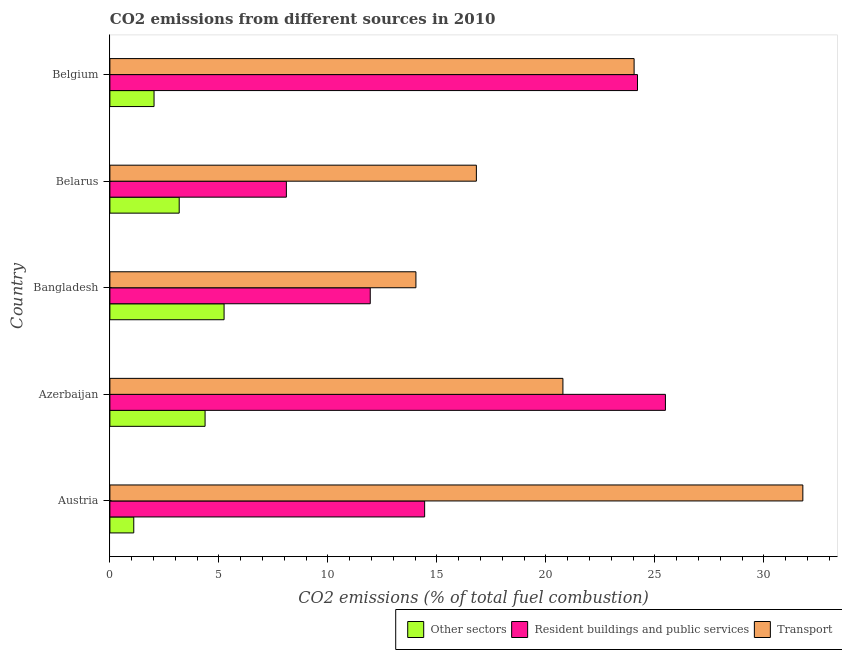How many groups of bars are there?
Your answer should be compact. 5. Are the number of bars on each tick of the Y-axis equal?
Provide a succinct answer. Yes. What is the percentage of co2 emissions from other sectors in Azerbaijan?
Provide a succinct answer. 4.37. Across all countries, what is the maximum percentage of co2 emissions from other sectors?
Offer a terse response. 5.24. Across all countries, what is the minimum percentage of co2 emissions from transport?
Give a very brief answer. 14.04. In which country was the percentage of co2 emissions from other sectors maximum?
Make the answer very short. Bangladesh. In which country was the percentage of co2 emissions from resident buildings and public services minimum?
Provide a short and direct response. Belarus. What is the total percentage of co2 emissions from other sectors in the graph?
Give a very brief answer. 15.9. What is the difference between the percentage of co2 emissions from resident buildings and public services in Azerbaijan and that in Belgium?
Provide a short and direct response. 1.28. What is the difference between the percentage of co2 emissions from transport in Bangladesh and the percentage of co2 emissions from other sectors in Azerbaijan?
Keep it short and to the point. 9.67. What is the average percentage of co2 emissions from other sectors per country?
Make the answer very short. 3.18. What is the difference between the percentage of co2 emissions from other sectors and percentage of co2 emissions from resident buildings and public services in Bangladesh?
Provide a succinct answer. -6.71. What is the ratio of the percentage of co2 emissions from transport in Austria to that in Belarus?
Offer a terse response. 1.89. Is the percentage of co2 emissions from transport in Bangladesh less than that in Belgium?
Provide a succinct answer. Yes. Is the difference between the percentage of co2 emissions from transport in Belarus and Belgium greater than the difference between the percentage of co2 emissions from resident buildings and public services in Belarus and Belgium?
Provide a succinct answer. Yes. What is the difference between the highest and the second highest percentage of co2 emissions from transport?
Keep it short and to the point. 7.74. What is the difference between the highest and the lowest percentage of co2 emissions from resident buildings and public services?
Your answer should be very brief. 17.39. What does the 2nd bar from the top in Austria represents?
Ensure brevity in your answer.  Resident buildings and public services. What does the 3rd bar from the bottom in Belarus represents?
Your response must be concise. Transport. Is it the case that in every country, the sum of the percentage of co2 emissions from other sectors and percentage of co2 emissions from resident buildings and public services is greater than the percentage of co2 emissions from transport?
Give a very brief answer. No. How many bars are there?
Offer a very short reply. 15. How many countries are there in the graph?
Give a very brief answer. 5. Are the values on the major ticks of X-axis written in scientific E-notation?
Your response must be concise. No. Does the graph contain any zero values?
Provide a short and direct response. No. Does the graph contain grids?
Your answer should be very brief. No. How are the legend labels stacked?
Offer a very short reply. Horizontal. What is the title of the graph?
Ensure brevity in your answer.  CO2 emissions from different sources in 2010. What is the label or title of the X-axis?
Keep it short and to the point. CO2 emissions (% of total fuel combustion). What is the label or title of the Y-axis?
Keep it short and to the point. Country. What is the CO2 emissions (% of total fuel combustion) in Other sectors in Austria?
Make the answer very short. 1.1. What is the CO2 emissions (% of total fuel combustion) in Resident buildings and public services in Austria?
Offer a very short reply. 14.44. What is the CO2 emissions (% of total fuel combustion) of Transport in Austria?
Offer a very short reply. 31.79. What is the CO2 emissions (% of total fuel combustion) of Other sectors in Azerbaijan?
Give a very brief answer. 4.37. What is the CO2 emissions (% of total fuel combustion) in Resident buildings and public services in Azerbaijan?
Your answer should be very brief. 25.48. What is the CO2 emissions (% of total fuel combustion) in Transport in Azerbaijan?
Your answer should be very brief. 20.78. What is the CO2 emissions (% of total fuel combustion) of Other sectors in Bangladesh?
Offer a terse response. 5.24. What is the CO2 emissions (% of total fuel combustion) of Resident buildings and public services in Bangladesh?
Your response must be concise. 11.94. What is the CO2 emissions (% of total fuel combustion) in Transport in Bangladesh?
Offer a very short reply. 14.04. What is the CO2 emissions (% of total fuel combustion) in Other sectors in Belarus?
Give a very brief answer. 3.18. What is the CO2 emissions (% of total fuel combustion) in Resident buildings and public services in Belarus?
Your answer should be very brief. 8.1. What is the CO2 emissions (% of total fuel combustion) of Transport in Belarus?
Keep it short and to the point. 16.81. What is the CO2 emissions (% of total fuel combustion) of Other sectors in Belgium?
Offer a very short reply. 2.03. What is the CO2 emissions (% of total fuel combustion) of Resident buildings and public services in Belgium?
Make the answer very short. 24.2. What is the CO2 emissions (% of total fuel combustion) of Transport in Belgium?
Ensure brevity in your answer.  24.05. Across all countries, what is the maximum CO2 emissions (% of total fuel combustion) of Other sectors?
Your answer should be very brief. 5.24. Across all countries, what is the maximum CO2 emissions (% of total fuel combustion) in Resident buildings and public services?
Your answer should be compact. 25.48. Across all countries, what is the maximum CO2 emissions (% of total fuel combustion) of Transport?
Ensure brevity in your answer.  31.79. Across all countries, what is the minimum CO2 emissions (% of total fuel combustion) in Other sectors?
Provide a short and direct response. 1.1. Across all countries, what is the minimum CO2 emissions (% of total fuel combustion) of Resident buildings and public services?
Give a very brief answer. 8.1. Across all countries, what is the minimum CO2 emissions (% of total fuel combustion) in Transport?
Give a very brief answer. 14.04. What is the total CO2 emissions (% of total fuel combustion) of Other sectors in the graph?
Provide a short and direct response. 15.9. What is the total CO2 emissions (% of total fuel combustion) in Resident buildings and public services in the graph?
Provide a succinct answer. 84.16. What is the total CO2 emissions (% of total fuel combustion) in Transport in the graph?
Offer a very short reply. 107.46. What is the difference between the CO2 emissions (% of total fuel combustion) of Other sectors in Austria and that in Azerbaijan?
Make the answer very short. -3.27. What is the difference between the CO2 emissions (% of total fuel combustion) of Resident buildings and public services in Austria and that in Azerbaijan?
Provide a succinct answer. -11.04. What is the difference between the CO2 emissions (% of total fuel combustion) in Transport in Austria and that in Azerbaijan?
Give a very brief answer. 11.01. What is the difference between the CO2 emissions (% of total fuel combustion) in Other sectors in Austria and that in Bangladesh?
Make the answer very short. -4.14. What is the difference between the CO2 emissions (% of total fuel combustion) in Resident buildings and public services in Austria and that in Bangladesh?
Offer a very short reply. 2.5. What is the difference between the CO2 emissions (% of total fuel combustion) of Transport in Austria and that in Bangladesh?
Make the answer very short. 17.75. What is the difference between the CO2 emissions (% of total fuel combustion) of Other sectors in Austria and that in Belarus?
Offer a terse response. -2.08. What is the difference between the CO2 emissions (% of total fuel combustion) in Resident buildings and public services in Austria and that in Belarus?
Provide a short and direct response. 6.34. What is the difference between the CO2 emissions (% of total fuel combustion) in Transport in Austria and that in Belarus?
Give a very brief answer. 14.98. What is the difference between the CO2 emissions (% of total fuel combustion) of Other sectors in Austria and that in Belgium?
Your response must be concise. -0.93. What is the difference between the CO2 emissions (% of total fuel combustion) in Resident buildings and public services in Austria and that in Belgium?
Your answer should be compact. -9.76. What is the difference between the CO2 emissions (% of total fuel combustion) in Transport in Austria and that in Belgium?
Ensure brevity in your answer.  7.74. What is the difference between the CO2 emissions (% of total fuel combustion) in Other sectors in Azerbaijan and that in Bangladesh?
Offer a terse response. -0.87. What is the difference between the CO2 emissions (% of total fuel combustion) in Resident buildings and public services in Azerbaijan and that in Bangladesh?
Your response must be concise. 13.54. What is the difference between the CO2 emissions (% of total fuel combustion) in Transport in Azerbaijan and that in Bangladesh?
Your answer should be compact. 6.74. What is the difference between the CO2 emissions (% of total fuel combustion) in Other sectors in Azerbaijan and that in Belarus?
Give a very brief answer. 1.19. What is the difference between the CO2 emissions (% of total fuel combustion) of Resident buildings and public services in Azerbaijan and that in Belarus?
Make the answer very short. 17.39. What is the difference between the CO2 emissions (% of total fuel combustion) in Transport in Azerbaijan and that in Belarus?
Provide a succinct answer. 3.97. What is the difference between the CO2 emissions (% of total fuel combustion) in Other sectors in Azerbaijan and that in Belgium?
Give a very brief answer. 2.34. What is the difference between the CO2 emissions (% of total fuel combustion) of Resident buildings and public services in Azerbaijan and that in Belgium?
Provide a short and direct response. 1.28. What is the difference between the CO2 emissions (% of total fuel combustion) of Transport in Azerbaijan and that in Belgium?
Ensure brevity in your answer.  -3.27. What is the difference between the CO2 emissions (% of total fuel combustion) in Other sectors in Bangladesh and that in Belarus?
Ensure brevity in your answer.  2.06. What is the difference between the CO2 emissions (% of total fuel combustion) in Resident buildings and public services in Bangladesh and that in Belarus?
Make the answer very short. 3.85. What is the difference between the CO2 emissions (% of total fuel combustion) in Transport in Bangladesh and that in Belarus?
Keep it short and to the point. -2.77. What is the difference between the CO2 emissions (% of total fuel combustion) of Other sectors in Bangladesh and that in Belgium?
Your answer should be very brief. 3.21. What is the difference between the CO2 emissions (% of total fuel combustion) of Resident buildings and public services in Bangladesh and that in Belgium?
Your answer should be very brief. -12.26. What is the difference between the CO2 emissions (% of total fuel combustion) in Transport in Bangladesh and that in Belgium?
Offer a terse response. -10.01. What is the difference between the CO2 emissions (% of total fuel combustion) in Other sectors in Belarus and that in Belgium?
Keep it short and to the point. 1.15. What is the difference between the CO2 emissions (% of total fuel combustion) in Resident buildings and public services in Belarus and that in Belgium?
Provide a short and direct response. -16.11. What is the difference between the CO2 emissions (% of total fuel combustion) of Transport in Belarus and that in Belgium?
Offer a terse response. -7.24. What is the difference between the CO2 emissions (% of total fuel combustion) of Other sectors in Austria and the CO2 emissions (% of total fuel combustion) of Resident buildings and public services in Azerbaijan?
Offer a very short reply. -24.39. What is the difference between the CO2 emissions (% of total fuel combustion) of Other sectors in Austria and the CO2 emissions (% of total fuel combustion) of Transport in Azerbaijan?
Make the answer very short. -19.69. What is the difference between the CO2 emissions (% of total fuel combustion) in Resident buildings and public services in Austria and the CO2 emissions (% of total fuel combustion) in Transport in Azerbaijan?
Give a very brief answer. -6.34. What is the difference between the CO2 emissions (% of total fuel combustion) in Other sectors in Austria and the CO2 emissions (% of total fuel combustion) in Resident buildings and public services in Bangladesh?
Make the answer very short. -10.85. What is the difference between the CO2 emissions (% of total fuel combustion) of Other sectors in Austria and the CO2 emissions (% of total fuel combustion) of Transport in Bangladesh?
Provide a succinct answer. -12.94. What is the difference between the CO2 emissions (% of total fuel combustion) of Resident buildings and public services in Austria and the CO2 emissions (% of total fuel combustion) of Transport in Bangladesh?
Provide a short and direct response. 0.4. What is the difference between the CO2 emissions (% of total fuel combustion) of Other sectors in Austria and the CO2 emissions (% of total fuel combustion) of Resident buildings and public services in Belarus?
Provide a short and direct response. -7. What is the difference between the CO2 emissions (% of total fuel combustion) of Other sectors in Austria and the CO2 emissions (% of total fuel combustion) of Transport in Belarus?
Provide a short and direct response. -15.72. What is the difference between the CO2 emissions (% of total fuel combustion) of Resident buildings and public services in Austria and the CO2 emissions (% of total fuel combustion) of Transport in Belarus?
Offer a very short reply. -2.37. What is the difference between the CO2 emissions (% of total fuel combustion) in Other sectors in Austria and the CO2 emissions (% of total fuel combustion) in Resident buildings and public services in Belgium?
Make the answer very short. -23.11. What is the difference between the CO2 emissions (% of total fuel combustion) of Other sectors in Austria and the CO2 emissions (% of total fuel combustion) of Transport in Belgium?
Keep it short and to the point. -22.95. What is the difference between the CO2 emissions (% of total fuel combustion) in Resident buildings and public services in Austria and the CO2 emissions (% of total fuel combustion) in Transport in Belgium?
Provide a succinct answer. -9.61. What is the difference between the CO2 emissions (% of total fuel combustion) in Other sectors in Azerbaijan and the CO2 emissions (% of total fuel combustion) in Resident buildings and public services in Bangladesh?
Offer a very short reply. -7.58. What is the difference between the CO2 emissions (% of total fuel combustion) of Other sectors in Azerbaijan and the CO2 emissions (% of total fuel combustion) of Transport in Bangladesh?
Offer a very short reply. -9.67. What is the difference between the CO2 emissions (% of total fuel combustion) in Resident buildings and public services in Azerbaijan and the CO2 emissions (% of total fuel combustion) in Transport in Bangladesh?
Give a very brief answer. 11.44. What is the difference between the CO2 emissions (% of total fuel combustion) of Other sectors in Azerbaijan and the CO2 emissions (% of total fuel combustion) of Resident buildings and public services in Belarus?
Provide a short and direct response. -3.73. What is the difference between the CO2 emissions (% of total fuel combustion) of Other sectors in Azerbaijan and the CO2 emissions (% of total fuel combustion) of Transport in Belarus?
Give a very brief answer. -12.45. What is the difference between the CO2 emissions (% of total fuel combustion) of Resident buildings and public services in Azerbaijan and the CO2 emissions (% of total fuel combustion) of Transport in Belarus?
Keep it short and to the point. 8.67. What is the difference between the CO2 emissions (% of total fuel combustion) in Other sectors in Azerbaijan and the CO2 emissions (% of total fuel combustion) in Resident buildings and public services in Belgium?
Provide a short and direct response. -19.84. What is the difference between the CO2 emissions (% of total fuel combustion) of Other sectors in Azerbaijan and the CO2 emissions (% of total fuel combustion) of Transport in Belgium?
Provide a short and direct response. -19.68. What is the difference between the CO2 emissions (% of total fuel combustion) in Resident buildings and public services in Azerbaijan and the CO2 emissions (% of total fuel combustion) in Transport in Belgium?
Ensure brevity in your answer.  1.44. What is the difference between the CO2 emissions (% of total fuel combustion) in Other sectors in Bangladesh and the CO2 emissions (% of total fuel combustion) in Resident buildings and public services in Belarus?
Your response must be concise. -2.86. What is the difference between the CO2 emissions (% of total fuel combustion) in Other sectors in Bangladesh and the CO2 emissions (% of total fuel combustion) in Transport in Belarus?
Make the answer very short. -11.57. What is the difference between the CO2 emissions (% of total fuel combustion) in Resident buildings and public services in Bangladesh and the CO2 emissions (% of total fuel combustion) in Transport in Belarus?
Your answer should be very brief. -4.87. What is the difference between the CO2 emissions (% of total fuel combustion) of Other sectors in Bangladesh and the CO2 emissions (% of total fuel combustion) of Resident buildings and public services in Belgium?
Provide a succinct answer. -18.96. What is the difference between the CO2 emissions (% of total fuel combustion) of Other sectors in Bangladesh and the CO2 emissions (% of total fuel combustion) of Transport in Belgium?
Give a very brief answer. -18.81. What is the difference between the CO2 emissions (% of total fuel combustion) of Resident buildings and public services in Bangladesh and the CO2 emissions (% of total fuel combustion) of Transport in Belgium?
Give a very brief answer. -12.1. What is the difference between the CO2 emissions (% of total fuel combustion) in Other sectors in Belarus and the CO2 emissions (% of total fuel combustion) in Resident buildings and public services in Belgium?
Keep it short and to the point. -21.02. What is the difference between the CO2 emissions (% of total fuel combustion) of Other sectors in Belarus and the CO2 emissions (% of total fuel combustion) of Transport in Belgium?
Your response must be concise. -20.87. What is the difference between the CO2 emissions (% of total fuel combustion) of Resident buildings and public services in Belarus and the CO2 emissions (% of total fuel combustion) of Transport in Belgium?
Ensure brevity in your answer.  -15.95. What is the average CO2 emissions (% of total fuel combustion) of Other sectors per country?
Offer a terse response. 3.18. What is the average CO2 emissions (% of total fuel combustion) in Resident buildings and public services per country?
Keep it short and to the point. 16.83. What is the average CO2 emissions (% of total fuel combustion) in Transport per country?
Your answer should be compact. 21.49. What is the difference between the CO2 emissions (% of total fuel combustion) in Other sectors and CO2 emissions (% of total fuel combustion) in Resident buildings and public services in Austria?
Provide a succinct answer. -13.34. What is the difference between the CO2 emissions (% of total fuel combustion) of Other sectors and CO2 emissions (% of total fuel combustion) of Transport in Austria?
Offer a very short reply. -30.69. What is the difference between the CO2 emissions (% of total fuel combustion) in Resident buildings and public services and CO2 emissions (% of total fuel combustion) in Transport in Austria?
Ensure brevity in your answer.  -17.35. What is the difference between the CO2 emissions (% of total fuel combustion) of Other sectors and CO2 emissions (% of total fuel combustion) of Resident buildings and public services in Azerbaijan?
Provide a short and direct response. -21.12. What is the difference between the CO2 emissions (% of total fuel combustion) in Other sectors and CO2 emissions (% of total fuel combustion) in Transport in Azerbaijan?
Offer a terse response. -16.41. What is the difference between the CO2 emissions (% of total fuel combustion) in Resident buildings and public services and CO2 emissions (% of total fuel combustion) in Transport in Azerbaijan?
Ensure brevity in your answer.  4.7. What is the difference between the CO2 emissions (% of total fuel combustion) of Other sectors and CO2 emissions (% of total fuel combustion) of Resident buildings and public services in Bangladesh?
Your answer should be very brief. -6.7. What is the difference between the CO2 emissions (% of total fuel combustion) in Other sectors and CO2 emissions (% of total fuel combustion) in Transport in Bangladesh?
Offer a terse response. -8.8. What is the difference between the CO2 emissions (% of total fuel combustion) in Resident buildings and public services and CO2 emissions (% of total fuel combustion) in Transport in Bangladesh?
Provide a short and direct response. -2.1. What is the difference between the CO2 emissions (% of total fuel combustion) of Other sectors and CO2 emissions (% of total fuel combustion) of Resident buildings and public services in Belarus?
Offer a terse response. -4.92. What is the difference between the CO2 emissions (% of total fuel combustion) in Other sectors and CO2 emissions (% of total fuel combustion) in Transport in Belarus?
Keep it short and to the point. -13.63. What is the difference between the CO2 emissions (% of total fuel combustion) in Resident buildings and public services and CO2 emissions (% of total fuel combustion) in Transport in Belarus?
Keep it short and to the point. -8.72. What is the difference between the CO2 emissions (% of total fuel combustion) in Other sectors and CO2 emissions (% of total fuel combustion) in Resident buildings and public services in Belgium?
Provide a succinct answer. -22.18. What is the difference between the CO2 emissions (% of total fuel combustion) in Other sectors and CO2 emissions (% of total fuel combustion) in Transport in Belgium?
Offer a terse response. -22.02. What is the difference between the CO2 emissions (% of total fuel combustion) of Resident buildings and public services and CO2 emissions (% of total fuel combustion) of Transport in Belgium?
Keep it short and to the point. 0.16. What is the ratio of the CO2 emissions (% of total fuel combustion) of Other sectors in Austria to that in Azerbaijan?
Provide a short and direct response. 0.25. What is the ratio of the CO2 emissions (% of total fuel combustion) in Resident buildings and public services in Austria to that in Azerbaijan?
Provide a short and direct response. 0.57. What is the ratio of the CO2 emissions (% of total fuel combustion) in Transport in Austria to that in Azerbaijan?
Keep it short and to the point. 1.53. What is the ratio of the CO2 emissions (% of total fuel combustion) in Other sectors in Austria to that in Bangladesh?
Ensure brevity in your answer.  0.21. What is the ratio of the CO2 emissions (% of total fuel combustion) in Resident buildings and public services in Austria to that in Bangladesh?
Your answer should be compact. 1.21. What is the ratio of the CO2 emissions (% of total fuel combustion) of Transport in Austria to that in Bangladesh?
Provide a succinct answer. 2.26. What is the ratio of the CO2 emissions (% of total fuel combustion) of Other sectors in Austria to that in Belarus?
Give a very brief answer. 0.34. What is the ratio of the CO2 emissions (% of total fuel combustion) in Resident buildings and public services in Austria to that in Belarus?
Ensure brevity in your answer.  1.78. What is the ratio of the CO2 emissions (% of total fuel combustion) in Transport in Austria to that in Belarus?
Give a very brief answer. 1.89. What is the ratio of the CO2 emissions (% of total fuel combustion) in Other sectors in Austria to that in Belgium?
Provide a short and direct response. 0.54. What is the ratio of the CO2 emissions (% of total fuel combustion) in Resident buildings and public services in Austria to that in Belgium?
Provide a succinct answer. 0.6. What is the ratio of the CO2 emissions (% of total fuel combustion) in Transport in Austria to that in Belgium?
Your answer should be compact. 1.32. What is the ratio of the CO2 emissions (% of total fuel combustion) in Other sectors in Azerbaijan to that in Bangladesh?
Keep it short and to the point. 0.83. What is the ratio of the CO2 emissions (% of total fuel combustion) in Resident buildings and public services in Azerbaijan to that in Bangladesh?
Ensure brevity in your answer.  2.13. What is the ratio of the CO2 emissions (% of total fuel combustion) in Transport in Azerbaijan to that in Bangladesh?
Offer a terse response. 1.48. What is the ratio of the CO2 emissions (% of total fuel combustion) in Other sectors in Azerbaijan to that in Belarus?
Your response must be concise. 1.37. What is the ratio of the CO2 emissions (% of total fuel combustion) in Resident buildings and public services in Azerbaijan to that in Belarus?
Provide a short and direct response. 3.15. What is the ratio of the CO2 emissions (% of total fuel combustion) of Transport in Azerbaijan to that in Belarus?
Your answer should be very brief. 1.24. What is the ratio of the CO2 emissions (% of total fuel combustion) of Other sectors in Azerbaijan to that in Belgium?
Provide a short and direct response. 2.16. What is the ratio of the CO2 emissions (% of total fuel combustion) of Resident buildings and public services in Azerbaijan to that in Belgium?
Offer a terse response. 1.05. What is the ratio of the CO2 emissions (% of total fuel combustion) in Transport in Azerbaijan to that in Belgium?
Your answer should be compact. 0.86. What is the ratio of the CO2 emissions (% of total fuel combustion) in Other sectors in Bangladesh to that in Belarus?
Give a very brief answer. 1.65. What is the ratio of the CO2 emissions (% of total fuel combustion) in Resident buildings and public services in Bangladesh to that in Belarus?
Your answer should be compact. 1.48. What is the ratio of the CO2 emissions (% of total fuel combustion) in Transport in Bangladesh to that in Belarus?
Provide a succinct answer. 0.83. What is the ratio of the CO2 emissions (% of total fuel combustion) of Other sectors in Bangladesh to that in Belgium?
Your response must be concise. 2.59. What is the ratio of the CO2 emissions (% of total fuel combustion) of Resident buildings and public services in Bangladesh to that in Belgium?
Keep it short and to the point. 0.49. What is the ratio of the CO2 emissions (% of total fuel combustion) of Transport in Bangladesh to that in Belgium?
Make the answer very short. 0.58. What is the ratio of the CO2 emissions (% of total fuel combustion) of Other sectors in Belarus to that in Belgium?
Provide a succinct answer. 1.57. What is the ratio of the CO2 emissions (% of total fuel combustion) in Resident buildings and public services in Belarus to that in Belgium?
Your answer should be very brief. 0.33. What is the ratio of the CO2 emissions (% of total fuel combustion) in Transport in Belarus to that in Belgium?
Give a very brief answer. 0.7. What is the difference between the highest and the second highest CO2 emissions (% of total fuel combustion) in Other sectors?
Offer a very short reply. 0.87. What is the difference between the highest and the second highest CO2 emissions (% of total fuel combustion) in Resident buildings and public services?
Keep it short and to the point. 1.28. What is the difference between the highest and the second highest CO2 emissions (% of total fuel combustion) of Transport?
Your response must be concise. 7.74. What is the difference between the highest and the lowest CO2 emissions (% of total fuel combustion) of Other sectors?
Offer a very short reply. 4.14. What is the difference between the highest and the lowest CO2 emissions (% of total fuel combustion) in Resident buildings and public services?
Provide a succinct answer. 17.39. What is the difference between the highest and the lowest CO2 emissions (% of total fuel combustion) in Transport?
Give a very brief answer. 17.75. 